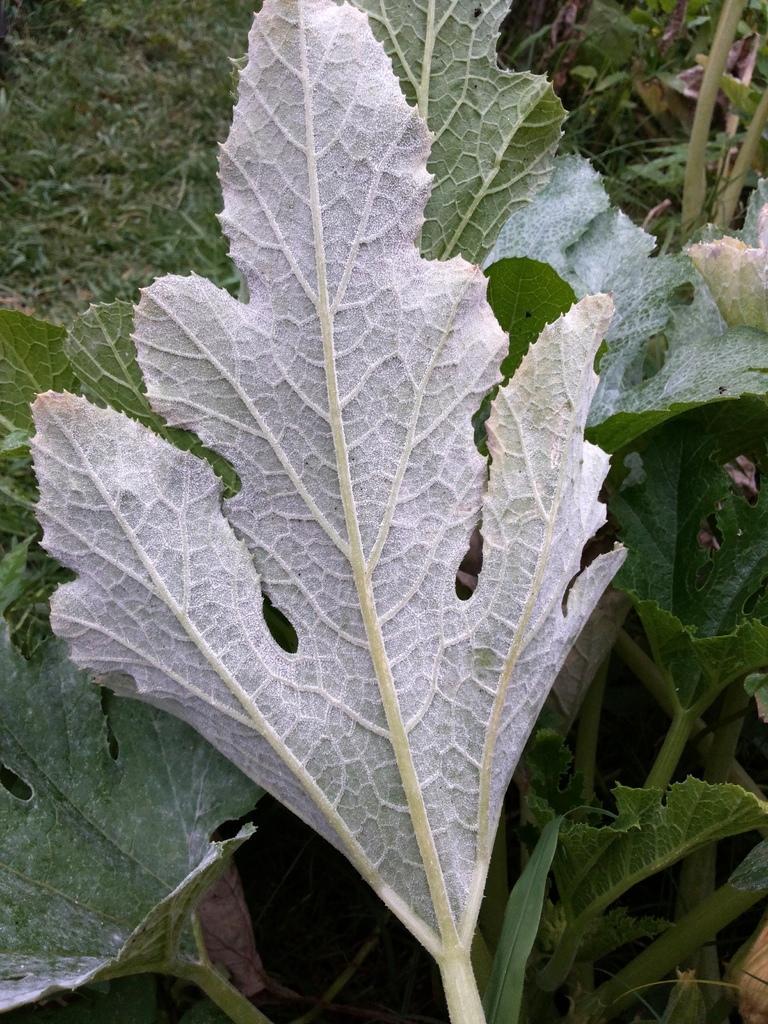Can you describe this image briefly? In this image we can see leaves in the middle of this image. There is a grassy land as we can see at the top left side of this image. 